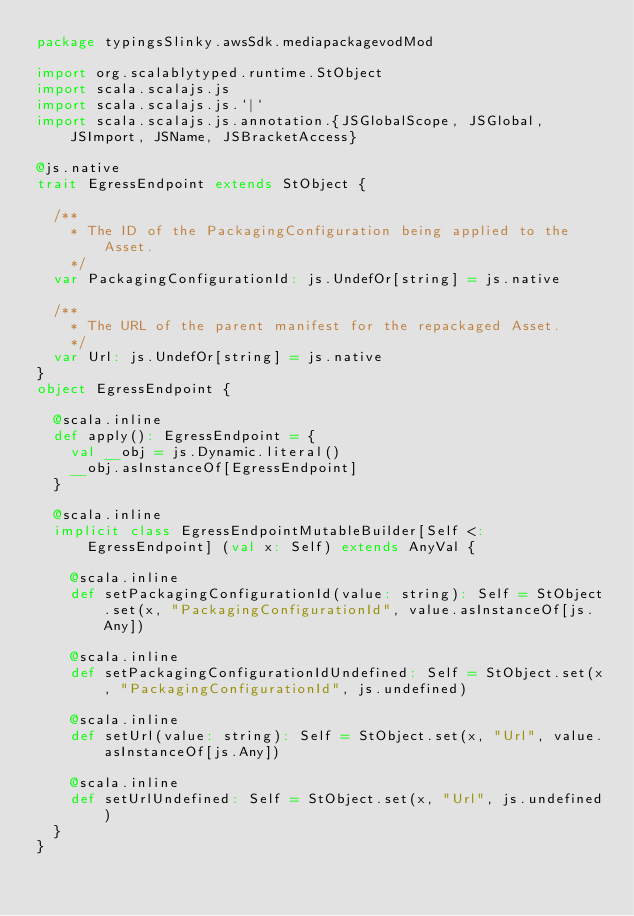<code> <loc_0><loc_0><loc_500><loc_500><_Scala_>package typingsSlinky.awsSdk.mediapackagevodMod

import org.scalablytyped.runtime.StObject
import scala.scalajs.js
import scala.scalajs.js.`|`
import scala.scalajs.js.annotation.{JSGlobalScope, JSGlobal, JSImport, JSName, JSBracketAccess}

@js.native
trait EgressEndpoint extends StObject {
  
  /**
    * The ID of the PackagingConfiguration being applied to the Asset.
    */
  var PackagingConfigurationId: js.UndefOr[string] = js.native
  
  /**
    * The URL of the parent manifest for the repackaged Asset.
    */
  var Url: js.UndefOr[string] = js.native
}
object EgressEndpoint {
  
  @scala.inline
  def apply(): EgressEndpoint = {
    val __obj = js.Dynamic.literal()
    __obj.asInstanceOf[EgressEndpoint]
  }
  
  @scala.inline
  implicit class EgressEndpointMutableBuilder[Self <: EgressEndpoint] (val x: Self) extends AnyVal {
    
    @scala.inline
    def setPackagingConfigurationId(value: string): Self = StObject.set(x, "PackagingConfigurationId", value.asInstanceOf[js.Any])
    
    @scala.inline
    def setPackagingConfigurationIdUndefined: Self = StObject.set(x, "PackagingConfigurationId", js.undefined)
    
    @scala.inline
    def setUrl(value: string): Self = StObject.set(x, "Url", value.asInstanceOf[js.Any])
    
    @scala.inline
    def setUrlUndefined: Self = StObject.set(x, "Url", js.undefined)
  }
}
</code> 